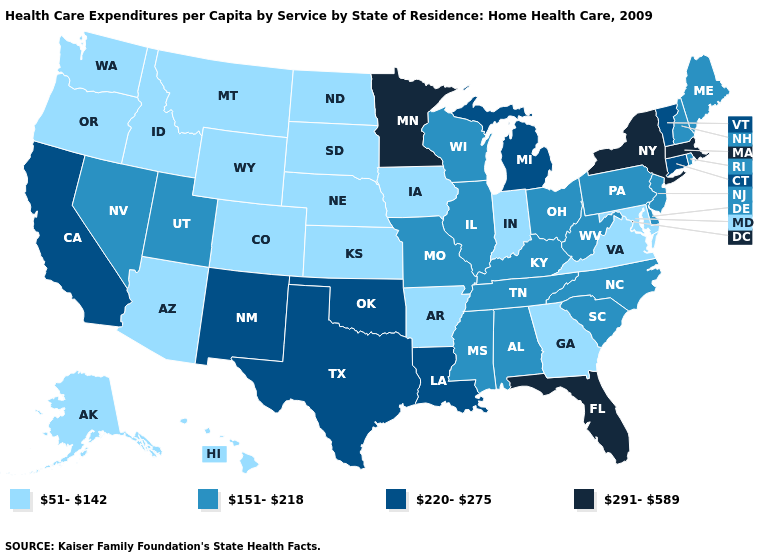Which states have the lowest value in the MidWest?
Write a very short answer. Indiana, Iowa, Kansas, Nebraska, North Dakota, South Dakota. What is the highest value in the USA?
Write a very short answer. 291-589. Which states have the lowest value in the USA?
Keep it brief. Alaska, Arizona, Arkansas, Colorado, Georgia, Hawaii, Idaho, Indiana, Iowa, Kansas, Maryland, Montana, Nebraska, North Dakota, Oregon, South Dakota, Virginia, Washington, Wyoming. Is the legend a continuous bar?
Keep it brief. No. What is the highest value in states that border South Carolina?
Give a very brief answer. 151-218. Is the legend a continuous bar?
Answer briefly. No. Is the legend a continuous bar?
Be succinct. No. What is the value of New Jersey?
Answer briefly. 151-218. What is the lowest value in states that border South Dakota?
Give a very brief answer. 51-142. Does Oklahoma have a higher value than Kentucky?
Short answer required. Yes. What is the value of Alabama?
Be succinct. 151-218. Does Delaware have a lower value than Wyoming?
Answer briefly. No. What is the lowest value in the USA?
Concise answer only. 51-142. Does Minnesota have the highest value in the MidWest?
Keep it brief. Yes. Does Oklahoma have a lower value than New York?
Be succinct. Yes. 